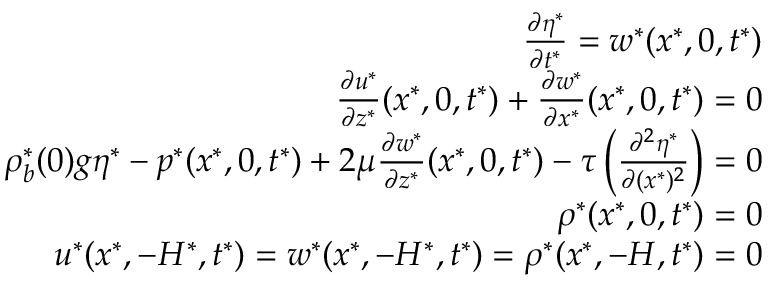Convert formula to latex. <formula><loc_0><loc_0><loc_500><loc_500>\begin{array} { r l r } & { \frac { \partial \eta ^ { * } } { \partial t ^ { * } } = w ^ { * } ( x ^ { * } , 0 , t ^ { * } ) } \\ & { \frac { \partial u ^ { * } } { \partial z ^ { * } } ( x ^ { * } , 0 , t ^ { * } ) + \frac { \partial w ^ { * } } { \partial x ^ { * } } ( x ^ { * } , 0 , t ^ { * } ) = 0 } \\ & { \rho _ { b } ^ { * } ( 0 ) g \eta ^ { * } - p ^ { * } ( x ^ { * } , 0 , t ^ { * } ) + 2 \mu \frac { \partial w ^ { * } } { \partial z ^ { * } } ( x ^ { * } , 0 , t ^ { * } ) - \tau \left ( \frac { \partial ^ { 2 } \eta ^ { * } } { \partial ( x ^ { * } ) ^ { 2 } } \right ) = 0 } \\ & { \rho ^ { * } ( x ^ { * } , 0 , t ^ { * } ) = 0 } \\ & { u ^ { * } ( x ^ { * } , - H ^ { * } , t ^ { * } ) = w ^ { * } ( x ^ { * } , - H ^ { * } , t ^ { * } ) = \rho ^ { * } ( x ^ { * } , - H , t ^ { * } ) = 0 } \end{array}</formula> 